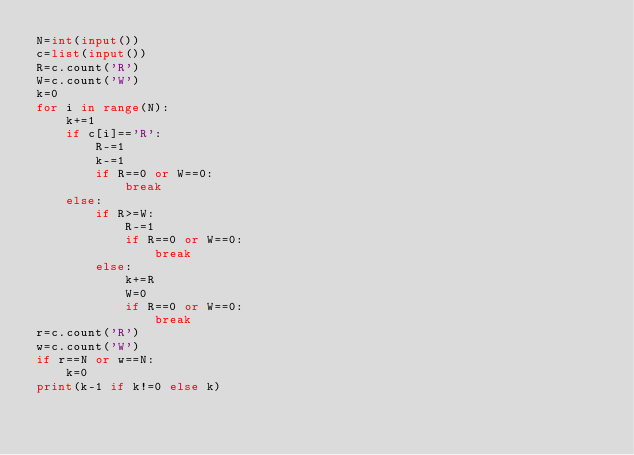<code> <loc_0><loc_0><loc_500><loc_500><_Python_>N=int(input())
c=list(input())
R=c.count('R')
W=c.count('W')
k=0
for i in range(N):
    k+=1
    if c[i]=='R':
        R-=1
        k-=1
        if R==0 or W==0:
            break
    else:
        if R>=W:
            R-=1
            if R==0 or W==0:
                break
        else:
            k+=R
            W=0
            if R==0 or W==0:
                break
r=c.count('R')
w=c.count('W')
if r==N or w==N:
    k=0
print(k-1 if k!=0 else k)</code> 